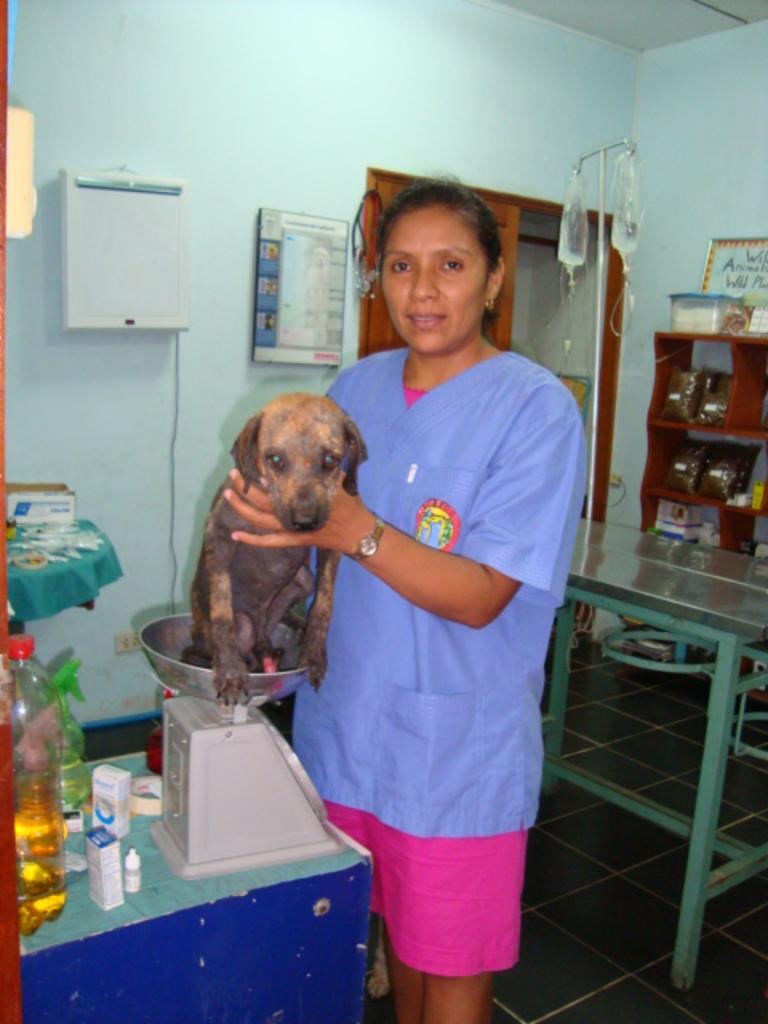In one or two sentences, can you explain what this image depicts? There is a woman holding a puppy dog and weighing her weight and there is a bottle with some liquid in a behind her very some Hospital machinery or equipment. 